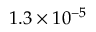<formula> <loc_0><loc_0><loc_500><loc_500>1 . 3 \times 1 0 ^ { - 5 }</formula> 